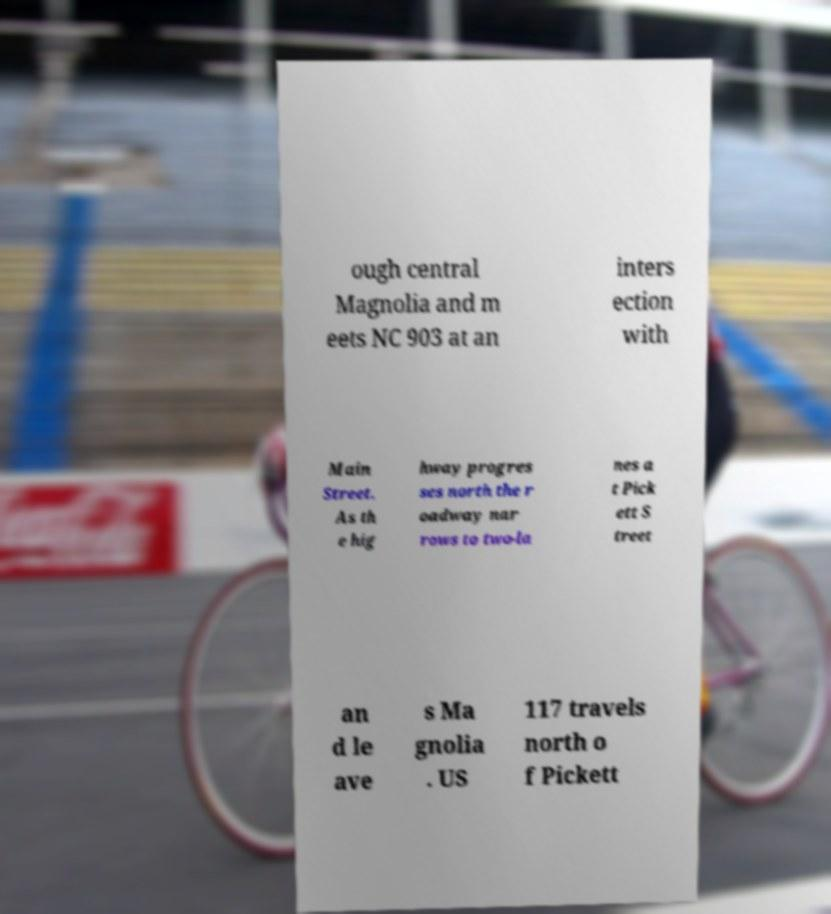I need the written content from this picture converted into text. Can you do that? ough central Magnolia and m eets NC 903 at an inters ection with Main Street. As th e hig hway progres ses north the r oadway nar rows to two-la nes a t Pick ett S treet an d le ave s Ma gnolia . US 117 travels north o f Pickett 